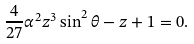<formula> <loc_0><loc_0><loc_500><loc_500>\frac { 4 } { 2 7 } \alpha ^ { 2 } z ^ { 3 } \sin ^ { 2 } \theta - z + 1 = 0 .</formula> 